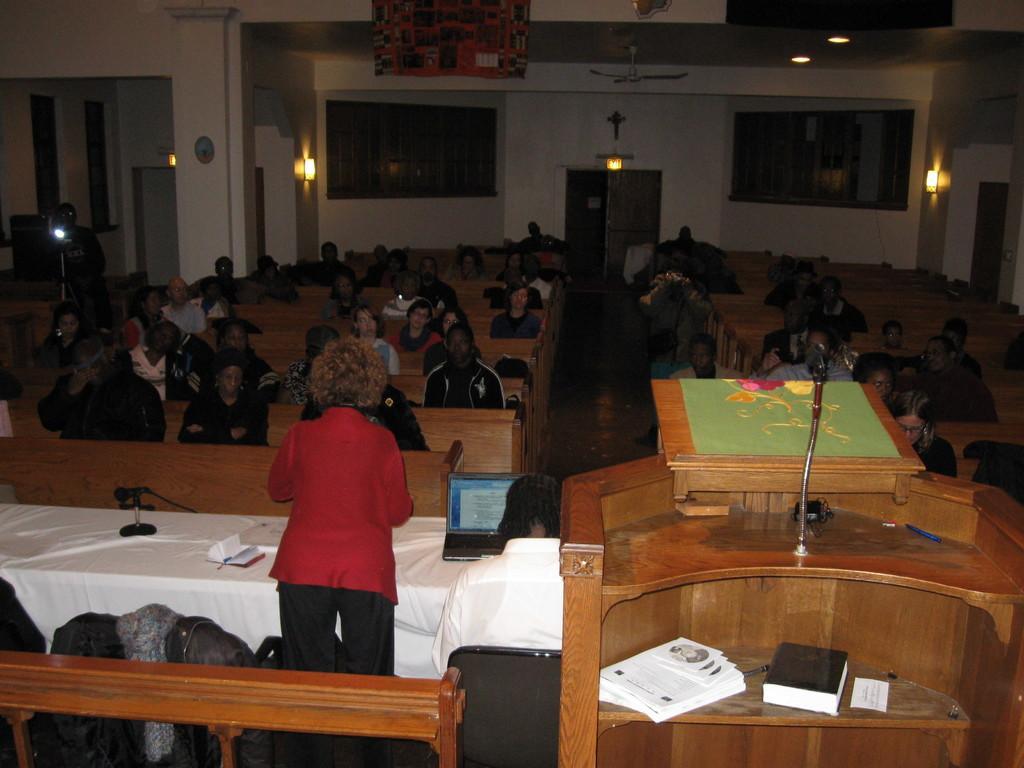Describe this image in one or two sentences. This picture shows a meeting room where all the people seated. we see a woman standing and speaking and we see a podium with a microphone on it and we see few books 